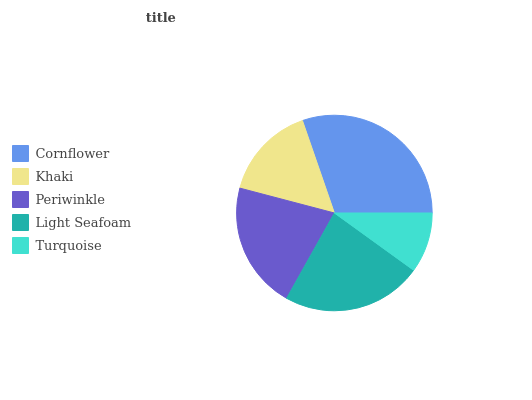Is Turquoise the minimum?
Answer yes or no. Yes. Is Cornflower the maximum?
Answer yes or no. Yes. Is Khaki the minimum?
Answer yes or no. No. Is Khaki the maximum?
Answer yes or no. No. Is Cornflower greater than Khaki?
Answer yes or no. Yes. Is Khaki less than Cornflower?
Answer yes or no. Yes. Is Khaki greater than Cornflower?
Answer yes or no. No. Is Cornflower less than Khaki?
Answer yes or no. No. Is Periwinkle the high median?
Answer yes or no. Yes. Is Periwinkle the low median?
Answer yes or no. Yes. Is Khaki the high median?
Answer yes or no. No. Is Khaki the low median?
Answer yes or no. No. 